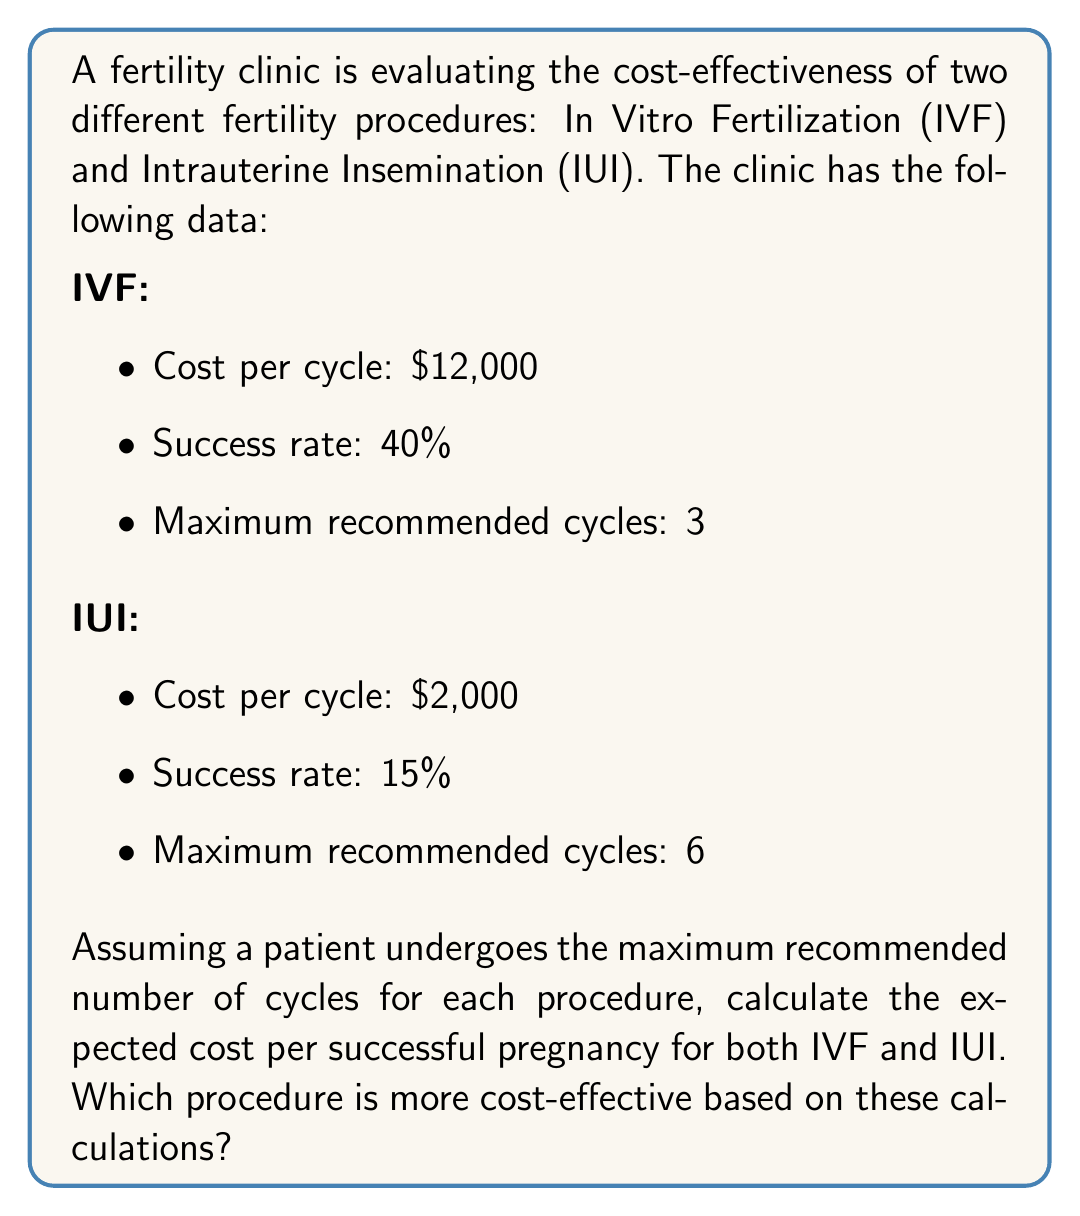Solve this math problem. To solve this problem, we need to calculate the expected cost per successful pregnancy for both IVF and IUI. We'll use the concept of expected value and the given information about costs, success rates, and maximum recommended cycles.

For IVF:
1. Probability of success in 3 cycles:
   $P(\text{IVF success}) = 1 - (1 - 0.40)^3 = 1 - 0.216 = 0.784$ or 78.4%

2. Expected number of cycles needed:
   $E(\text{IVF cycles}) = \frac{1}{0.40} = 2.5$ cycles

3. Expected cost:
   $E(\text{IVF cost}) = $12,000 \times 2.5 = $30,000$

4. Expected cost per successful pregnancy:
   $E(\text{IVF cost per success}) = \frac{$30,000}{0.784} = $38,265.31$

For IUI:
1. Probability of success in 6 cycles:
   $P(\text{IUI success}) = 1 - (1 - 0.15)^6 = 1 - 0.377 = 0.623$ or 62.3%

2. Expected number of cycles needed:
   $E(\text{IUI cycles}) = \frac{1}{0.15} = 6.67$ cycles

3. Expected cost:
   $E(\text{IUI cost}) = $2,000 \times 6 = $12,000$ (limited to maximum 6 cycles)

4. Expected cost per successful pregnancy:
   $E(\text{IUI cost per success}) = \frac{$12,000}{0.623} = $19,261.64$

Comparing the expected costs per successful pregnancy:
- IVF: $38,265.31
- IUI: $19,261.64

IUI has a lower expected cost per successful pregnancy, making it more cost-effective based on these calculations.
Answer: IUI is more cost-effective with an expected cost per successful pregnancy of $19,261.64, compared to IVF at $38,265.31. 